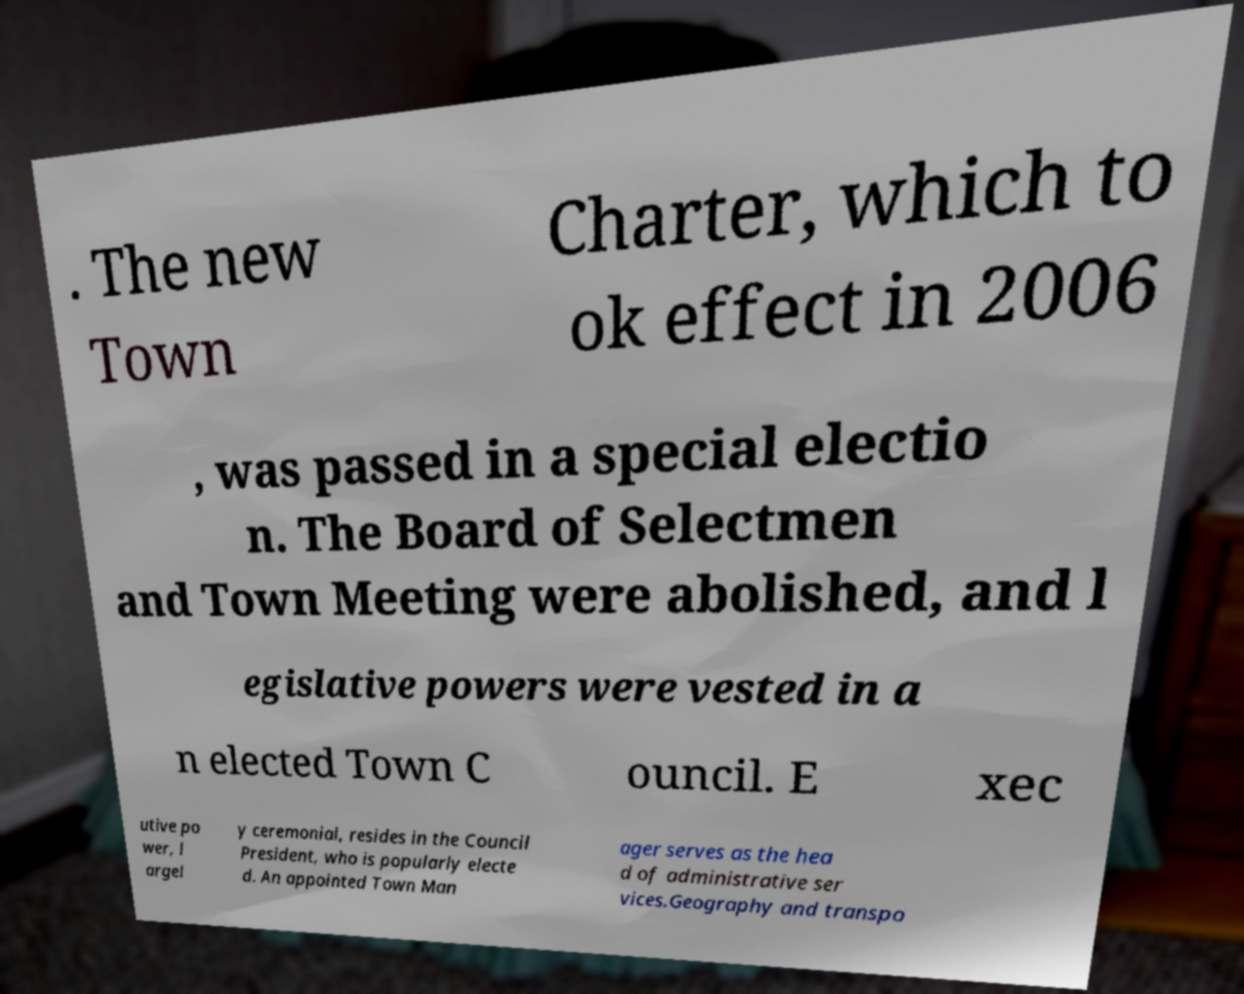Could you assist in decoding the text presented in this image and type it out clearly? . The new Town Charter, which to ok effect in 2006 , was passed in a special electio n. The Board of Selectmen and Town Meeting were abolished, and l egislative powers were vested in a n elected Town C ouncil. E xec utive po wer, l argel y ceremonial, resides in the Council President, who is popularly electe d. An appointed Town Man ager serves as the hea d of administrative ser vices.Geography and transpo 